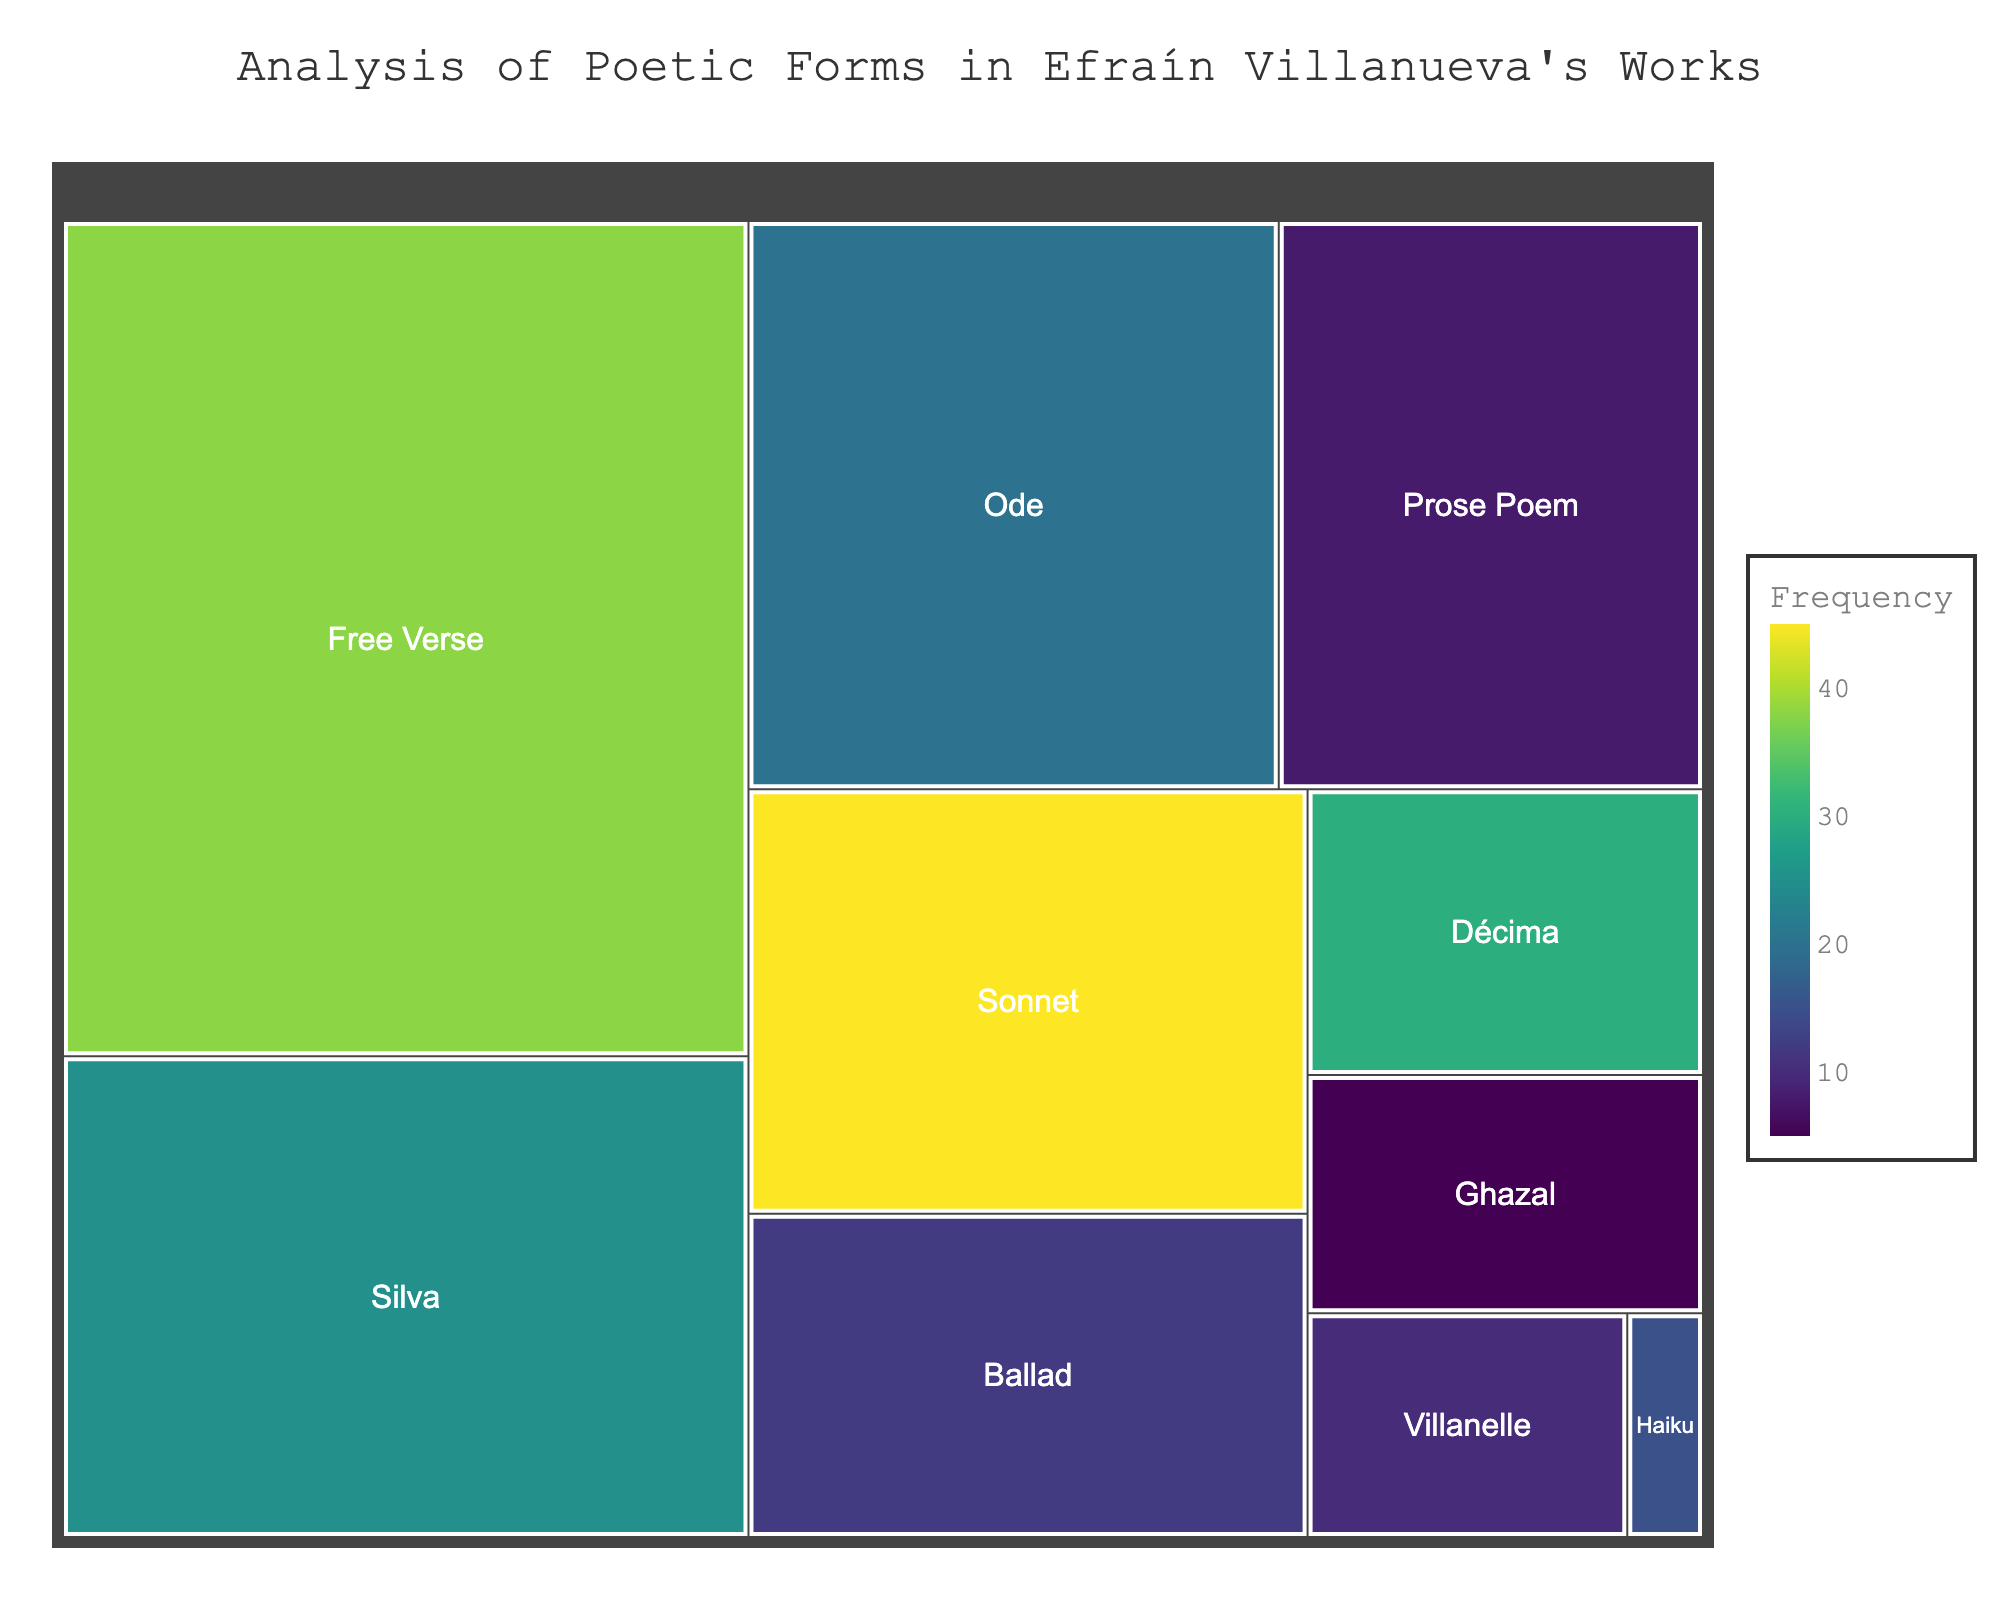What is the most frequently used poetic form in Efraín Villanueva's works? By observing the element with the highest "Frequency" value in the figure, we see that the Sonnet has the highest frequency at 45.
Answer: Sonnet Which poetic form has the highest word count? By looking at the element with the largest "Word_Count" value, the Free Verse is noted with a word count of 1520.
Answer: Free Verse What is the total word count for all the forms combined? Summing up the "Word_Count" values (630 + 1520 + 300 + 875 + 800 + 45 + 480 + 190 + 640 + 250), we get 5730.
Answer: 5730 How does the frequency of Free Verse compare to the frequency of Décima? By comparing their frequencies, Free Verse has a frequency of 38, while Décima has a frequency of 30. Free Verse is more frequent.
Answer: Free Verse is more frequent Which forms have a frequency less than 10? By identifying forms with "Frequency" values less than 10, the Villanelle (10), Prose Poem (8), and Ghazal (5) are noted.
Answer: Prose Poem, Ghazal Which form has the highest word count per frequency ratio? Calculating the word count per frequency ratio for each form and comparing: 
Sonnet: 630/45 = 14 
Free Verse: 1520/38 = 40 
Décima: 300/30 = 10 
Silva: 875/25 = 35 
Ode: 800/20 = 40 
Haiku: 45/15 = 3 
Ballad: 480/12 = 40 
Villanelle: 190/10 = 19 
Prose Poem: 640/8 = 80 
Ghazal: 250/5 = 50 
The Prose Poem has the highest ratio of 80.
Answer: Prose Poem How does the word count of Silva compare to Ode? Comparing the "Word_Count" values, Silva has 875 and Ode has 800. Silva has a higher word count.
Answer: Silva In which range does the word count for Haiku fall? Observing the "Word_Count" value for Haiku, which is 45, it falls between 0 and 50.
Answer: 0-50 Is there any form with a frequency exactly equal to 10? By looking at the frequency values, the Villanelle has a frequency of exactly 10.
Answer: Villanelle Which form has the smallest word count, and what is its frequency? The Haiku has the smallest word count of 45, and its frequency is 15.
Answer: Haiku, 15 